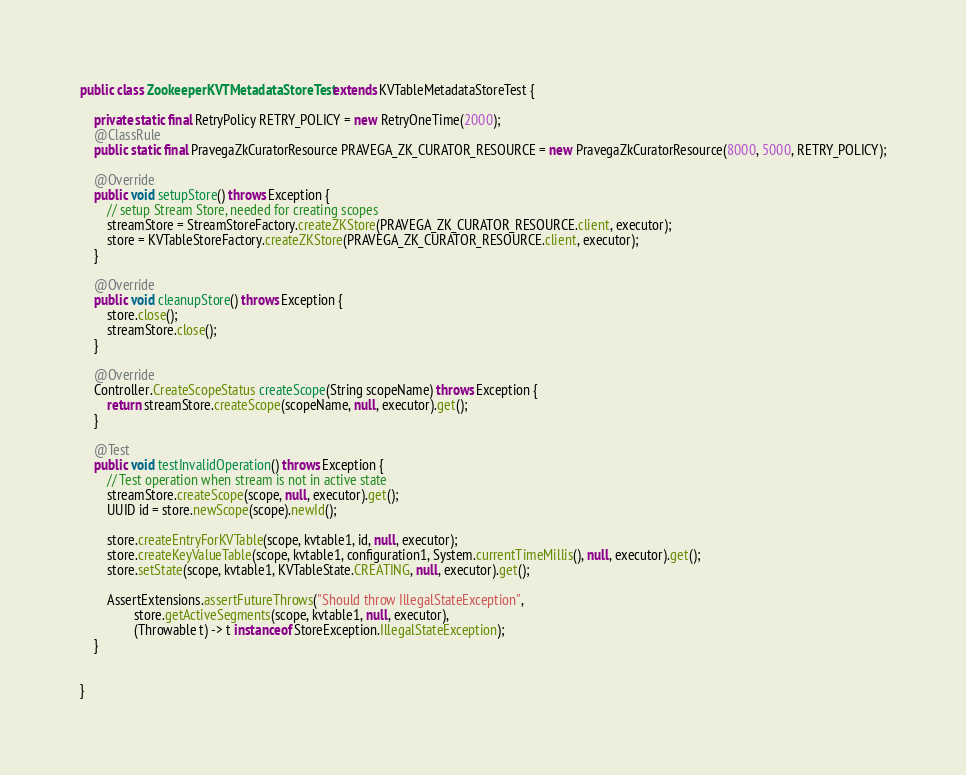<code> <loc_0><loc_0><loc_500><loc_500><_Java_>public class ZookeeperKVTMetadataStoreTest extends KVTableMetadataStoreTest {

    private static final RetryPolicy RETRY_POLICY = new RetryOneTime(2000);
    @ClassRule
    public static final PravegaZkCuratorResource PRAVEGA_ZK_CURATOR_RESOURCE = new PravegaZkCuratorResource(8000, 5000, RETRY_POLICY);

    @Override
    public void setupStore() throws Exception {
        // setup Stream Store, needed for creating scopes
        streamStore = StreamStoreFactory.createZKStore(PRAVEGA_ZK_CURATOR_RESOURCE.client, executor);
        store = KVTableStoreFactory.createZKStore(PRAVEGA_ZK_CURATOR_RESOURCE.client, executor);
    }

    @Override
    public void cleanupStore() throws Exception {
        store.close();
        streamStore.close();
    }

    @Override
    Controller.CreateScopeStatus createScope(String scopeName) throws Exception {
        return streamStore.createScope(scopeName, null, executor).get();
    }
    
    @Test
    public void testInvalidOperation() throws Exception {
        // Test operation when stream is not in active state
        streamStore.createScope(scope, null, executor).get();
        UUID id = store.newScope(scope).newId();

        store.createEntryForKVTable(scope, kvtable1, id, null, executor);
        store.createKeyValueTable(scope, kvtable1, configuration1, System.currentTimeMillis(), null, executor).get();
        store.setState(scope, kvtable1, KVTableState.CREATING, null, executor).get();

        AssertExtensions.assertFutureThrows("Should throw IllegalStateException",
                store.getActiveSegments(scope, kvtable1, null, executor),
                (Throwable t) -> t instanceof StoreException.IllegalStateException);
    }


}
</code> 